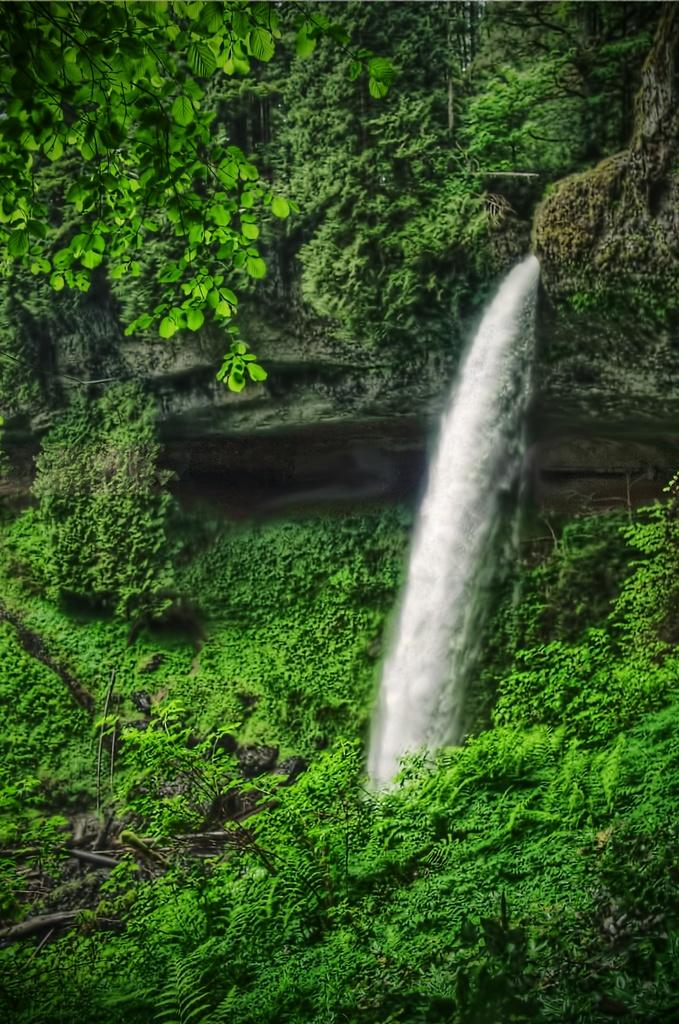What is the main feature of the image? There is a huge rocky mountain in the image. What can be seen on the mountain? There are trees on the mountain, which are green in color. What natural feature is present in the image? There is a waterfall in the image. What type of playground equipment can be seen near the waterfall in the image? There is no playground equipment present in the image; it features a huge rocky mountain, green trees, and a waterfall. Can you tell me the material of the brass statue near the waterfall in the image? There is no brass statue present in the image; it only features a huge rocky mountain, green trees, and a waterfall. 